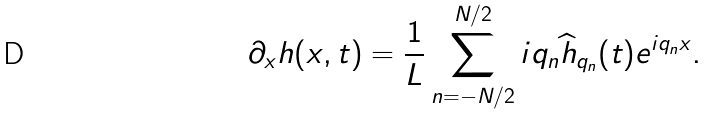<formula> <loc_0><loc_0><loc_500><loc_500>\partial _ { x } h ( x , t ) = \frac { 1 } { L } \sum _ { n = - N / 2 } ^ { N / 2 } i q _ { n } \widehat { h } _ { q _ { n } } ( t ) e ^ { { i } q _ { n } x } .</formula> 